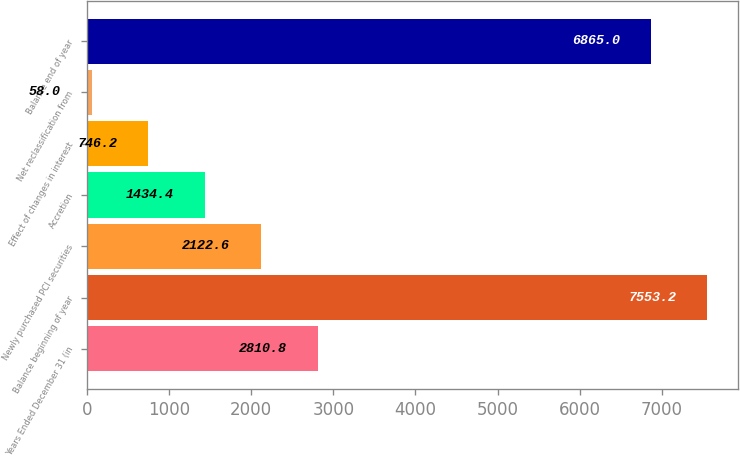<chart> <loc_0><loc_0><loc_500><loc_500><bar_chart><fcel>Years Ended December 31 (in<fcel>Balance beginning of year<fcel>Newly purchased PCI securities<fcel>Accretion<fcel>Effect of changes in interest<fcel>Net reclassification from<fcel>Balance end of year<nl><fcel>2810.8<fcel>7553.2<fcel>2122.6<fcel>1434.4<fcel>746.2<fcel>58<fcel>6865<nl></chart> 